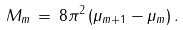<formula> <loc_0><loc_0><loc_500><loc_500>M _ { m } \, = \, 8 \pi ^ { 2 } \, ( \mu _ { m + 1 } - \mu _ { m } ) \, .</formula> 